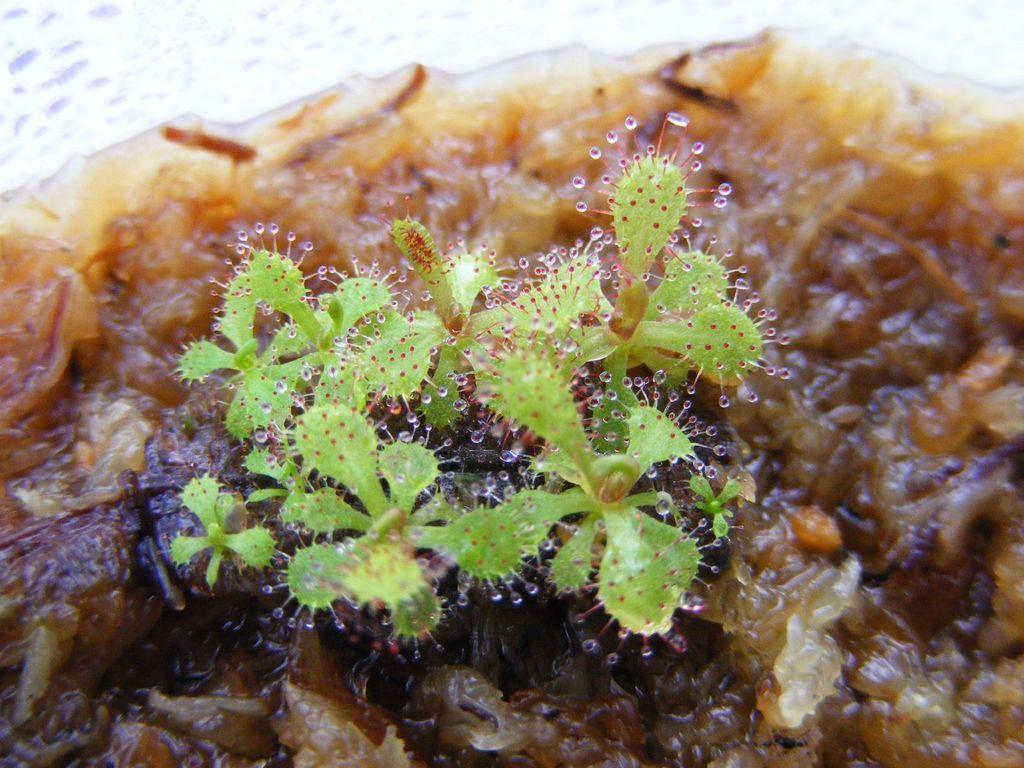What type of plants are visible in the image? There are aquatic plants in the image. What store can be seen selling these aquatic plants in the image? There is no store present in the image; it only features aquatic plants. 